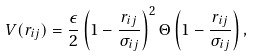Convert formula to latex. <formula><loc_0><loc_0><loc_500><loc_500>V ( r _ { i j } ) = \frac { \epsilon } { 2 } \left ( 1 - \frac { r _ { i j } } { \sigma _ { i j } } \right ) ^ { 2 } \Theta \left ( 1 - \frac { r _ { i j } } { \sigma _ { i j } } \right ) ,</formula> 